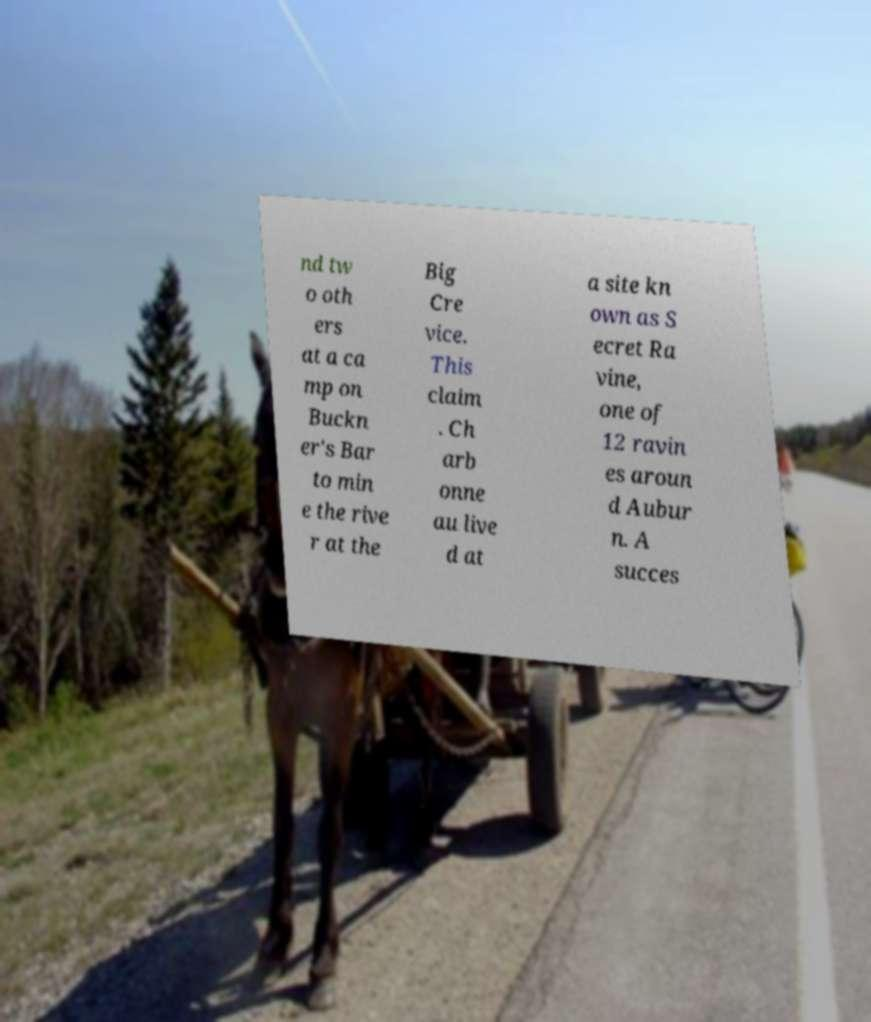What messages or text are displayed in this image? I need them in a readable, typed format. nd tw o oth ers at a ca mp on Buckn er's Bar to min e the rive r at the Big Cre vice. This claim . Ch arb onne au live d at a site kn own as S ecret Ra vine, one of 12 ravin es aroun d Aubur n. A succes 